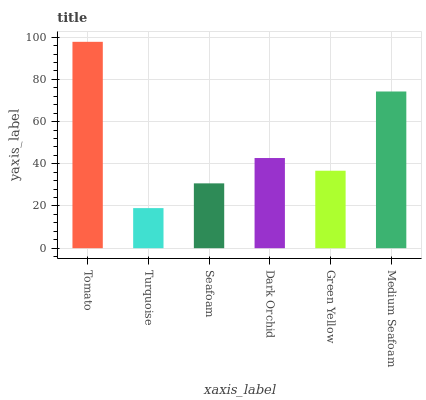Is Turquoise the minimum?
Answer yes or no. Yes. Is Tomato the maximum?
Answer yes or no. Yes. Is Seafoam the minimum?
Answer yes or no. No. Is Seafoam the maximum?
Answer yes or no. No. Is Seafoam greater than Turquoise?
Answer yes or no. Yes. Is Turquoise less than Seafoam?
Answer yes or no. Yes. Is Turquoise greater than Seafoam?
Answer yes or no. No. Is Seafoam less than Turquoise?
Answer yes or no. No. Is Dark Orchid the high median?
Answer yes or no. Yes. Is Green Yellow the low median?
Answer yes or no. Yes. Is Seafoam the high median?
Answer yes or no. No. Is Dark Orchid the low median?
Answer yes or no. No. 